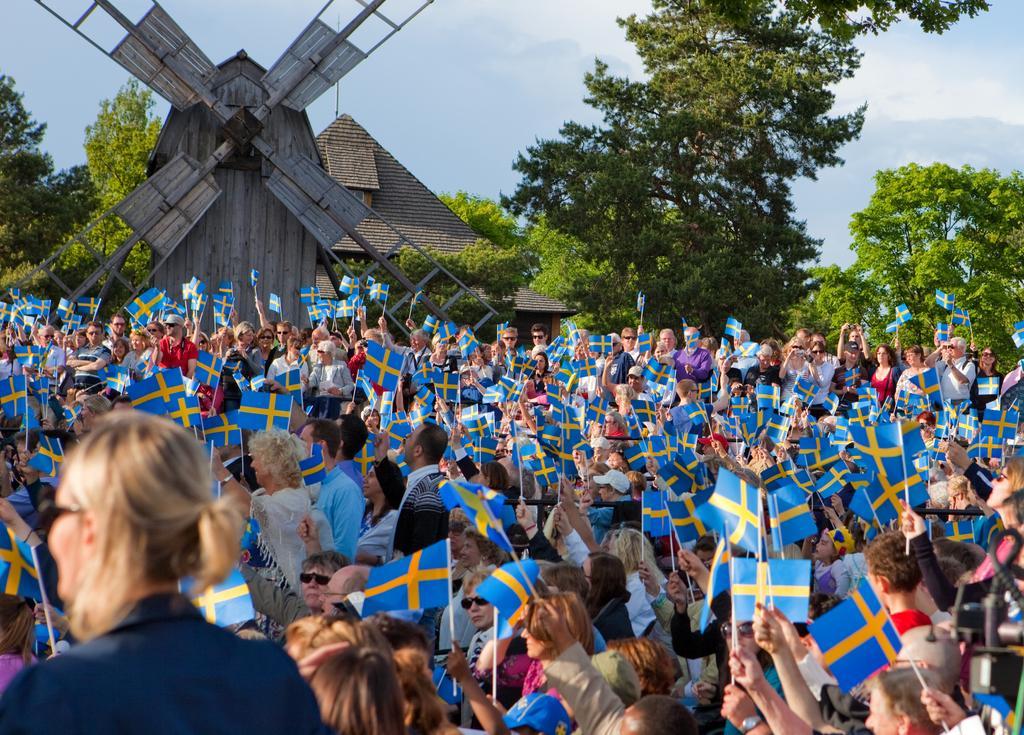Describe this image in one or two sentences. There is a huge crowd,all of them are holding their country flag in their hand and in front of the crowd there is a wooden fan with four wings and beside that there are many trees. 